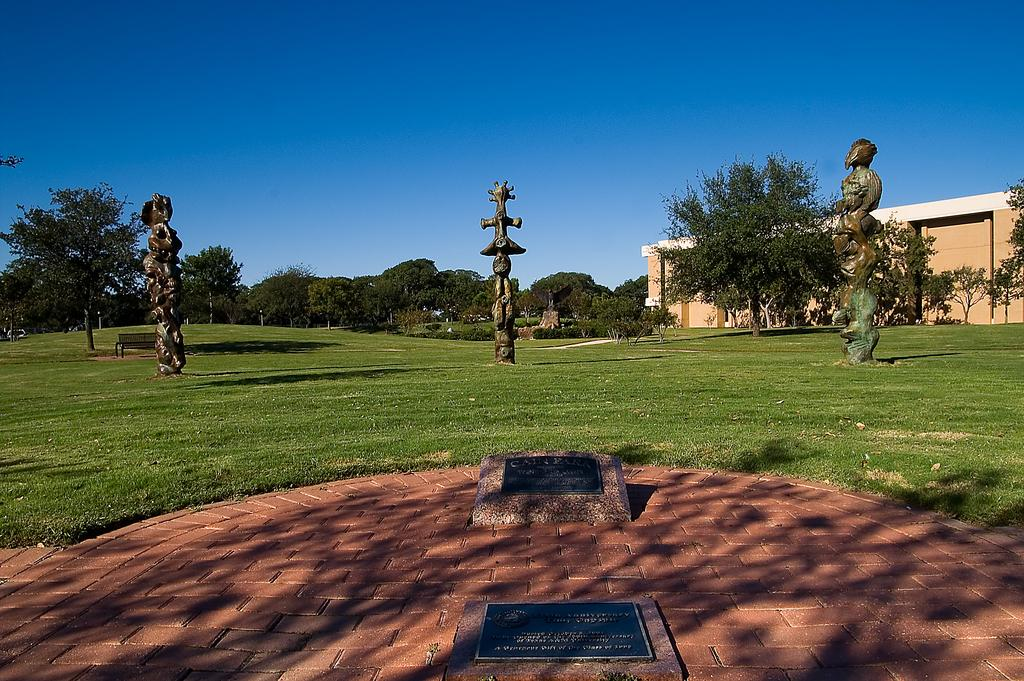What type of structures can be seen in the image? There are statues and buildings in the image. What else is present in the image besides structures? There are poles, trees, a bench, and stones on the ground in the image. Where is the bench located in the image? The bench is at the bottom of the image. How many sofas are there in the image? There are no sofas present in the image. What role does the mother play in the image? There is no mention of a mother or any people in the image. 